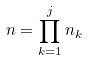<formula> <loc_0><loc_0><loc_500><loc_500>n = \prod _ { k = 1 } ^ { j } n _ { k }</formula> 